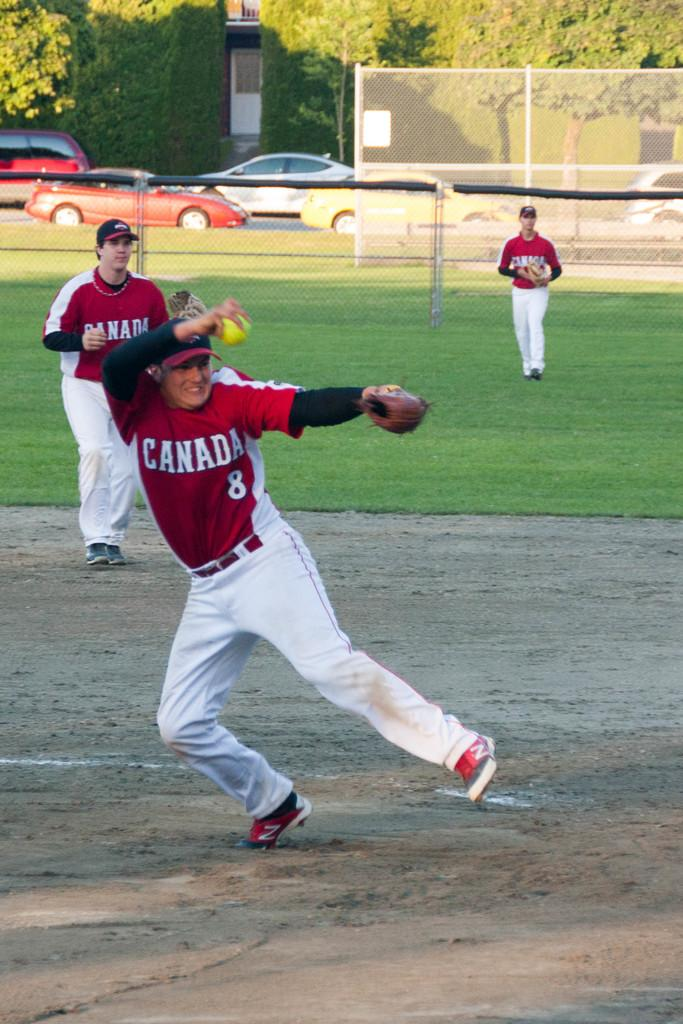Provide a one-sentence caption for the provided image. a player that has the word Canada on it. 